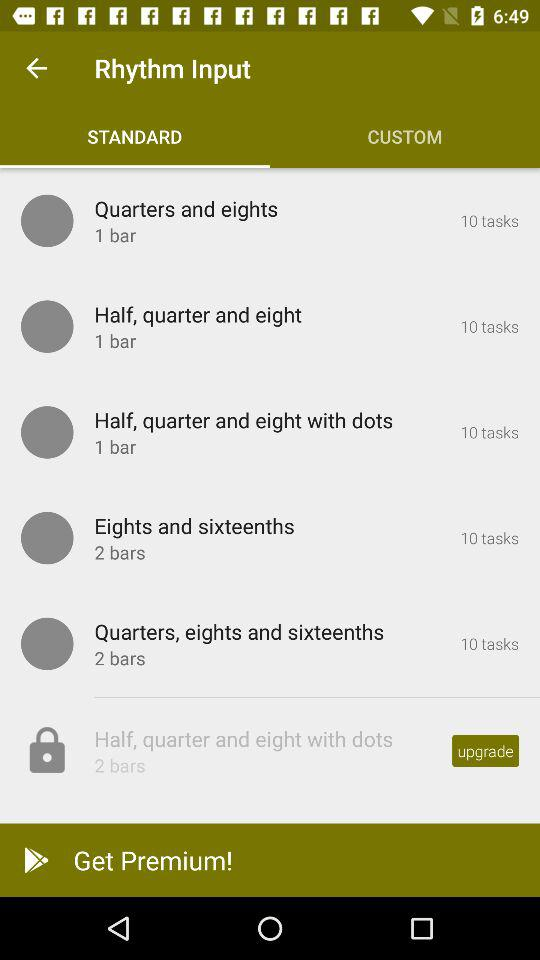How many tasks are there in "Eights and sixteenths"? There are 10 tasks. 